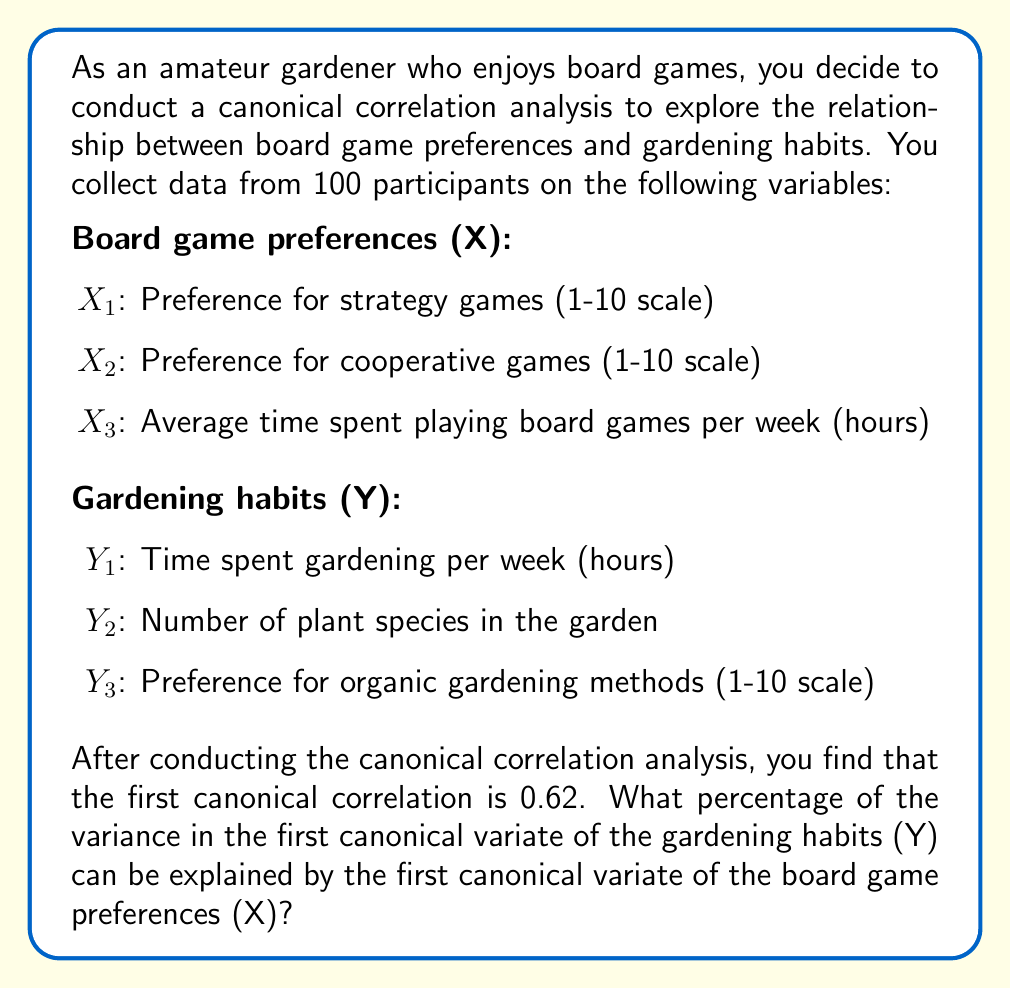Provide a solution to this math problem. To solve this problem, we need to understand the concept of canonical correlation and how it relates to explained variance. Let's break it down step-by-step:

1. Canonical correlation analysis (CCA) aims to find linear combinations of variables in two sets (X and Y) that have maximum correlation with each other.

2. The canonical correlation coefficient (r) represents the strength of the relationship between these linear combinations (canonical variates).

3. In this case, we're given that the first canonical correlation is 0.62.

4. To find the percentage of variance in the first canonical variate of Y explained by the first canonical variate of X, we need to square the canonical correlation coefficient.

5. The squared canonical correlation (r²) represents the proportion of variance shared between the two canonical variates.

6. To convert this proportion to a percentage, we multiply by 100.

Therefore, the calculation is:

$$r^2 = (0.62)^2 = 0.3844$$

$$\text{Percentage of variance explained} = 0.3844 \times 100 = 38.44\%$$

This means that 38.44% of the variance in the first canonical variate of the gardening habits (Y) can be explained by the first canonical variate of the board game preferences (X).
Answer: 38.44% 